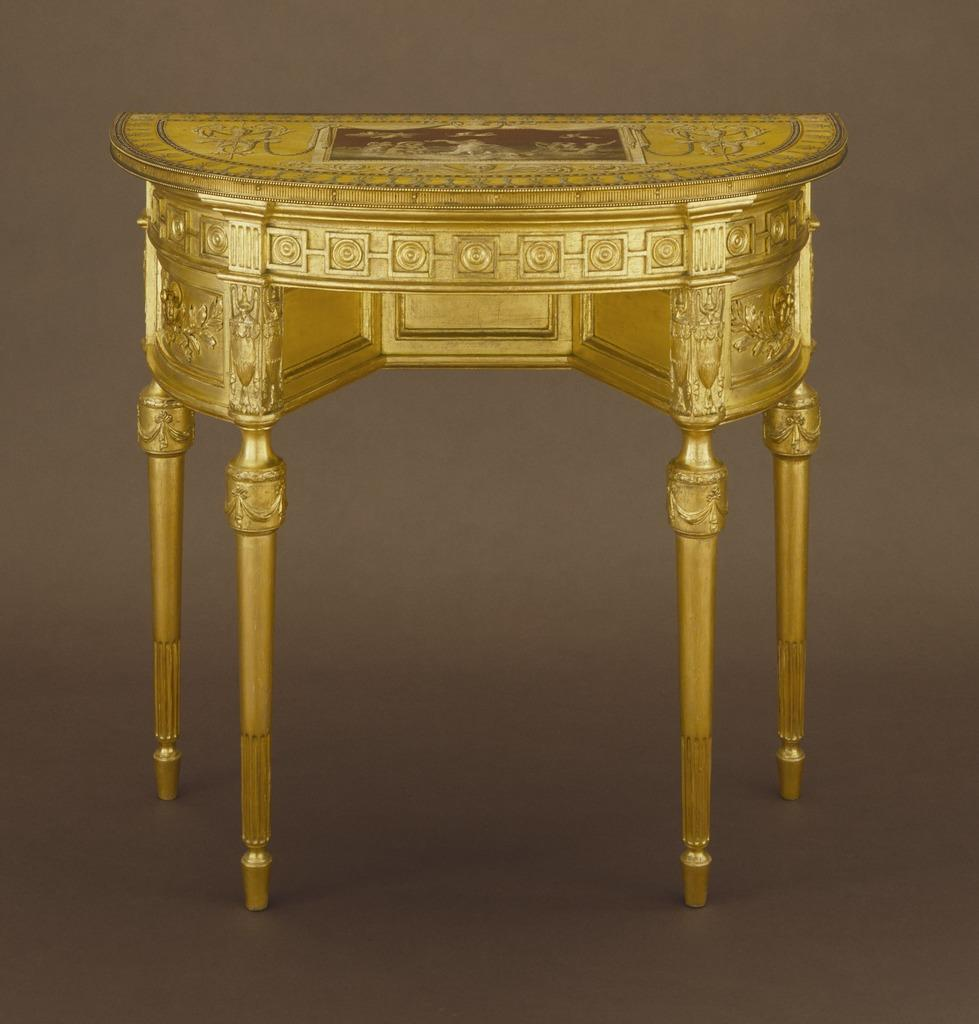What color is the table in the image? The table in the image is golden in color. How is the table positioned in the image? The table is placed on the ground. Is there a hose attached to the table in the image? No, there is no hose present in the image. Can you see a zipper on the table in the image? No, there is no zipper on the table in the image. 